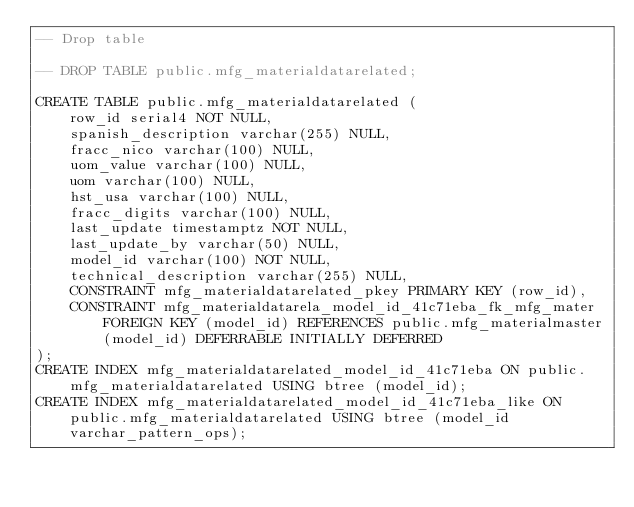Convert code to text. <code><loc_0><loc_0><loc_500><loc_500><_SQL_>-- Drop table

-- DROP TABLE public.mfg_materialdatarelated;

CREATE TABLE public.mfg_materialdatarelated (
	row_id serial4 NOT NULL,
	spanish_description varchar(255) NULL,
	fracc_nico varchar(100) NULL,
	uom_value varchar(100) NULL,
	uom varchar(100) NULL,
	hst_usa varchar(100) NULL,
	fracc_digits varchar(100) NULL,
	last_update timestamptz NOT NULL,
	last_update_by varchar(50) NULL,
	model_id varchar(100) NOT NULL,
	technical_description varchar(255) NULL,
	CONSTRAINT mfg_materialdatarelated_pkey PRIMARY KEY (row_id),
	CONSTRAINT mfg_materialdatarela_model_id_41c71eba_fk_mfg_mater FOREIGN KEY (model_id) REFERENCES public.mfg_materialmaster(model_id) DEFERRABLE INITIALLY DEFERRED
);
CREATE INDEX mfg_materialdatarelated_model_id_41c71eba ON public.mfg_materialdatarelated USING btree (model_id);
CREATE INDEX mfg_materialdatarelated_model_id_41c71eba_like ON public.mfg_materialdatarelated USING btree (model_id varchar_pattern_ops);
</code> 